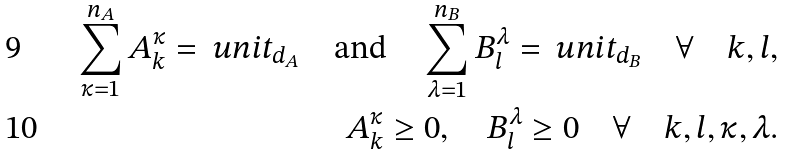<formula> <loc_0><loc_0><loc_500><loc_500>\sum _ { \kappa = 1 } ^ { n _ { A } } A ^ { \kappa } _ { k } = \ u n i t _ { d _ { A } } \quad \text {and} \quad \sum _ { \lambda = 1 } ^ { n _ { B } } B ^ { \lambda } _ { l } = \ u n i t _ { d _ { B } } \quad \forall \quad k , l , \\ A ^ { \kappa } _ { k } \geq 0 , \quad B ^ { \lambda } _ { l } \geq 0 \quad \forall \quad k , l , \kappa , \lambda .</formula> 